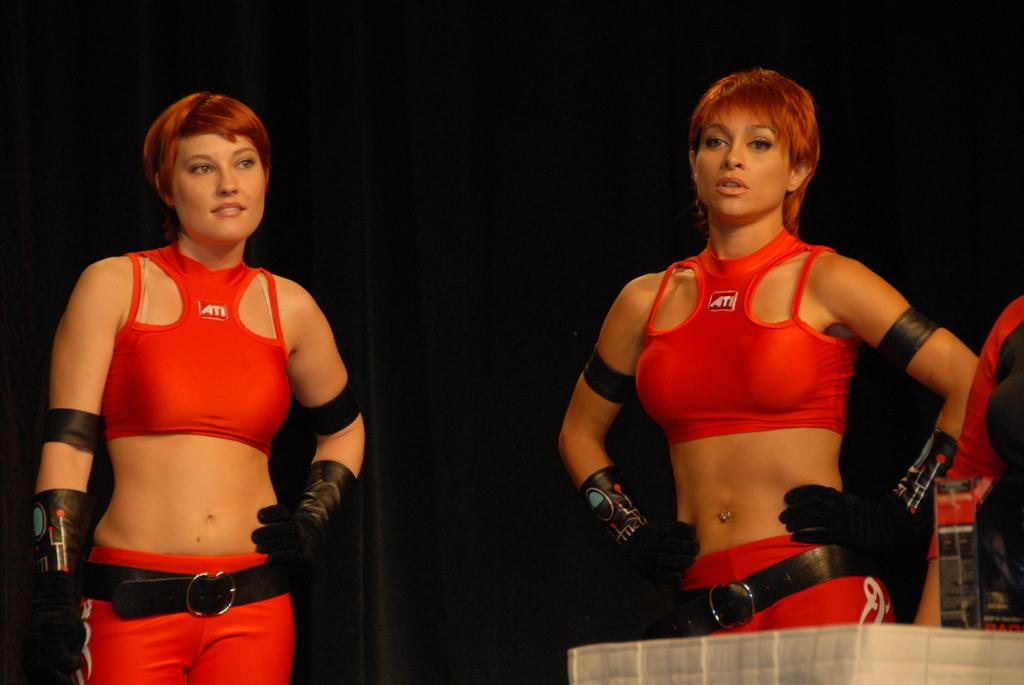<image>
Offer a succinct explanation of the picture presented. Two women are wearing red outfits with the word ATI on them. 